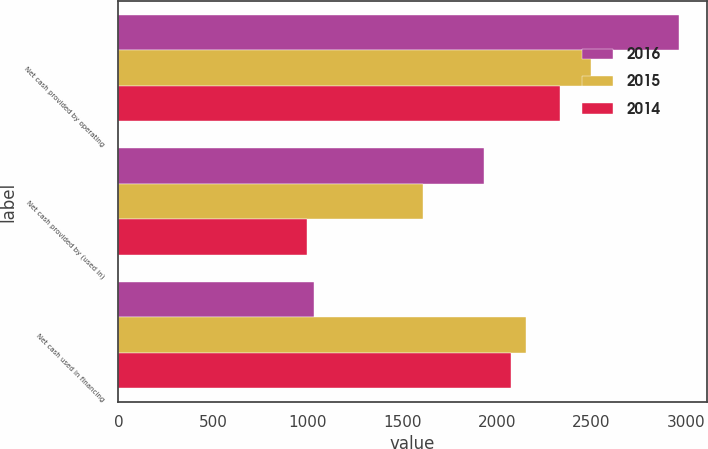<chart> <loc_0><loc_0><loc_500><loc_500><stacked_bar_chart><ecel><fcel>Net cash provided by operating<fcel>Net cash provided by (used in)<fcel>Net cash used in financing<nl><fcel>2016<fcel>2960<fcel>1932<fcel>1035<nl><fcel>2015<fcel>2498<fcel>1608<fcel>2155<nl><fcel>2014<fcel>2331<fcel>995<fcel>2072<nl></chart> 